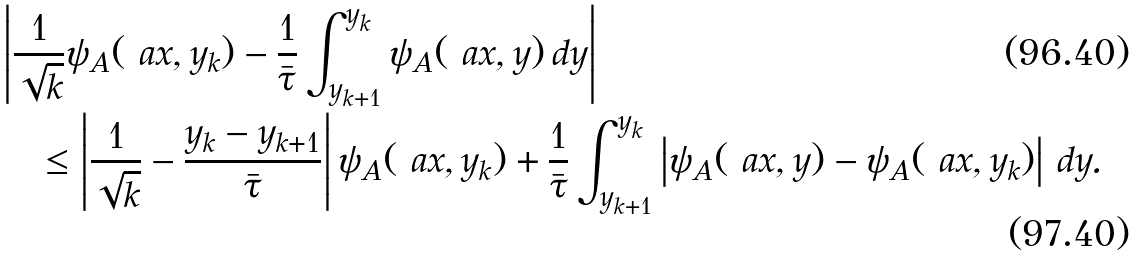<formula> <loc_0><loc_0><loc_500><loc_500>& \left | \frac { 1 } { \sqrt { k } } \psi _ { A } ( \ a x , y _ { k } ) - \frac { 1 } { \bar { \tau } } \int _ { y _ { k + 1 } } ^ { y _ { k } } \psi _ { A } ( \ a x , y ) \, d y \right | \\ & \quad \leq \left | \frac { 1 } { \sqrt { k } } - \frac { y _ { k } - y _ { k + 1 } } { \bar { \tau } } \right | \psi _ { A } ( \ a x , y _ { k } ) + \frac { 1 } { \bar { \tau } } \int _ { y _ { k + 1 } } ^ { y _ { k } } \left | \psi _ { A } ( \ a x , y ) - \psi _ { A } ( \ a x , y _ { k } ) \right | \, d y .</formula> 